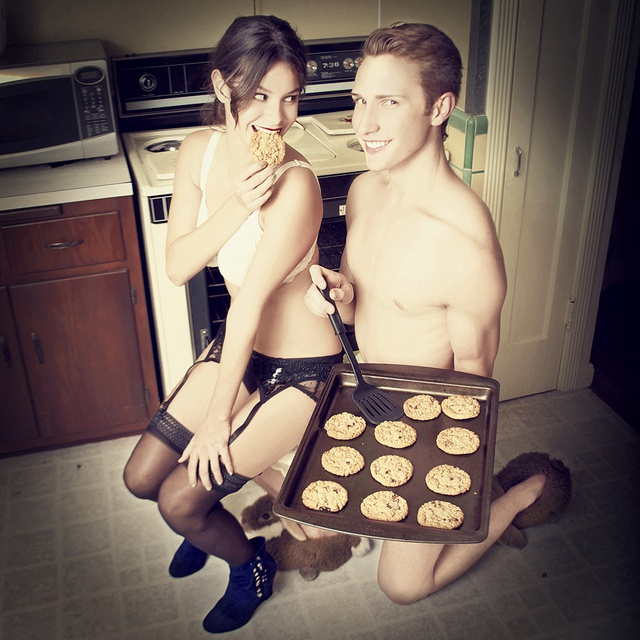Describe the objects in this image and their specific colors. I can see people in black, tan, and beige tones, people in black, beige, tan, and gray tones, oven in black, beige, tan, and gray tones, and microwave in black, gray, and darkgray tones in this image. 